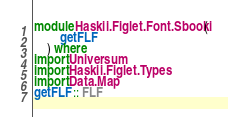<code> <loc_0><loc_0><loc_500><loc_500><_Haskell_>module Haskii.Figlet.Font.Sbooki (
        getFLF
    ) where
import Universum
import Haskii.Figlet.Types
import Data.Map
getFLF :: FLF</code> 